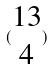Convert formula to latex. <formula><loc_0><loc_0><loc_500><loc_500>( \begin{matrix} 1 3 \\ 4 \end{matrix} )</formula> 